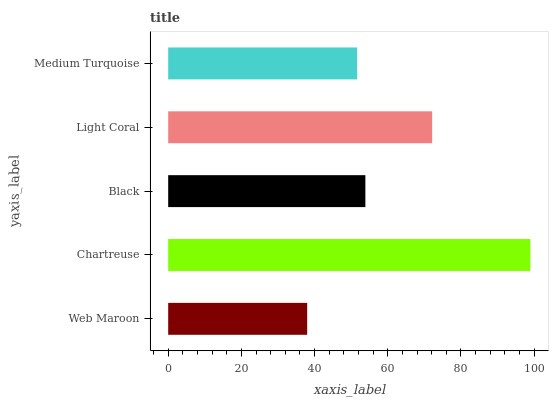Is Web Maroon the minimum?
Answer yes or no. Yes. Is Chartreuse the maximum?
Answer yes or no. Yes. Is Black the minimum?
Answer yes or no. No. Is Black the maximum?
Answer yes or no. No. Is Chartreuse greater than Black?
Answer yes or no. Yes. Is Black less than Chartreuse?
Answer yes or no. Yes. Is Black greater than Chartreuse?
Answer yes or no. No. Is Chartreuse less than Black?
Answer yes or no. No. Is Black the high median?
Answer yes or no. Yes. Is Black the low median?
Answer yes or no. Yes. Is Medium Turquoise the high median?
Answer yes or no. No. Is Medium Turquoise the low median?
Answer yes or no. No. 